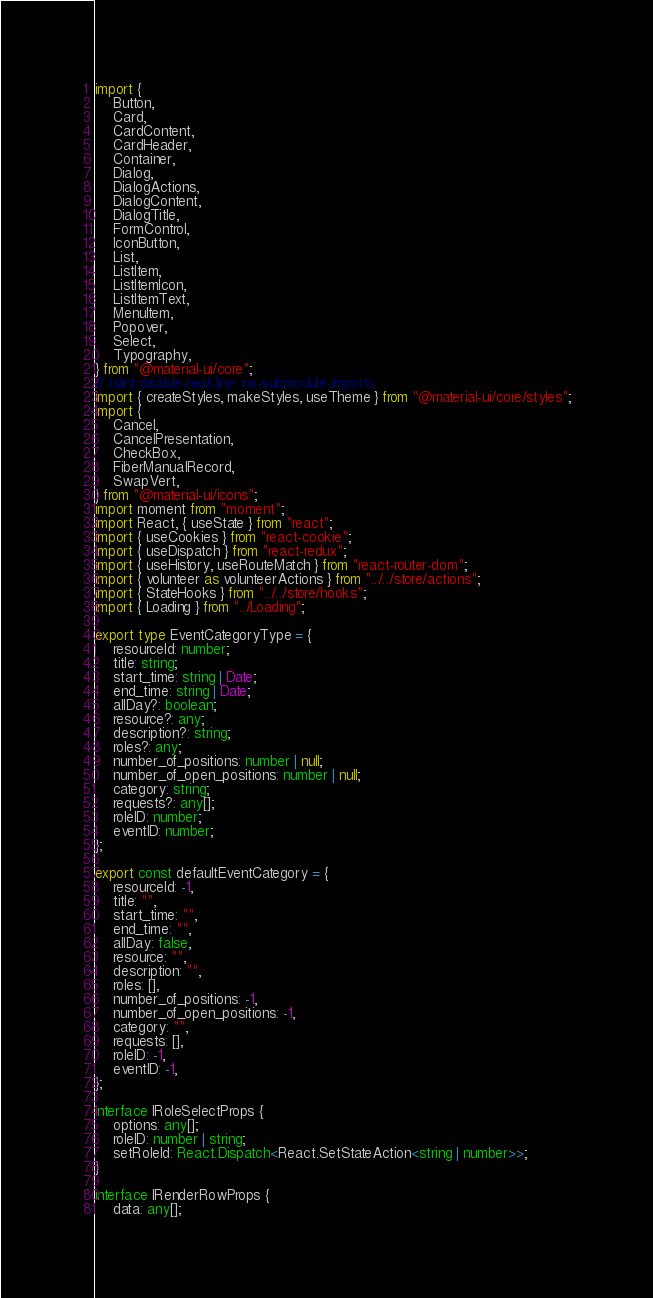<code> <loc_0><loc_0><loc_500><loc_500><_TypeScript_>import {
    Button,
    Card,
    CardContent,
    CardHeader,
    Container,
    Dialog,
    DialogActions,
    DialogContent,
    DialogTitle,
    FormControl,
    IconButton,
    List,
    ListItem,
    ListItemIcon,
    ListItemText,
    MenuItem,
    Popover,
    Select,
    Typography,
} from "@material-ui/core";
// tslint:disable-next-line: no-submodule-imports
import { createStyles, makeStyles, useTheme } from "@material-ui/core/styles";
import {
    Cancel,
    CancelPresentation,
    CheckBox,
    FiberManualRecord,
    SwapVert,
} from "@material-ui/icons";
import moment from "moment";
import React, { useState } from "react";
import { useCookies } from "react-cookie";
import { useDispatch } from "react-redux";
import { useHistory, useRouteMatch } from "react-router-dom";
import { volunteer as volunteerActions } from "../../store/actions";
import { StateHooks } from "../../store/hooks";
import { Loading } from "../Loading";

export type EventCategoryType = {
    resourceId: number;
    title: string;
    start_time: string | Date;
    end_time: string | Date;
    allDay?: boolean;
    resource?: any;
    description?: string;
    roles?: any;
    number_of_positions: number | null;
    number_of_open_positions: number | null;
    category: string;
    requests?: any[];
    roleID: number;
    eventID: number;
};

export const defaultEventCategory = {
    resourceId: -1,
    title: "",
    start_time: "",
    end_time: "",
    allDay: false,
    resource: "",
    description: "",
    roles: [],
    number_of_positions: -1,
    number_of_open_positions: -1,
    category: "",
    requests: [],
    roleID: -1,
    eventID: -1,
};

interface IRoleSelectProps {
    options: any[];
    roleID: number | string;
    setRoleId: React.Dispatch<React.SetStateAction<string | number>>;
}

interface IRenderRowProps {
    data: any[];</code> 